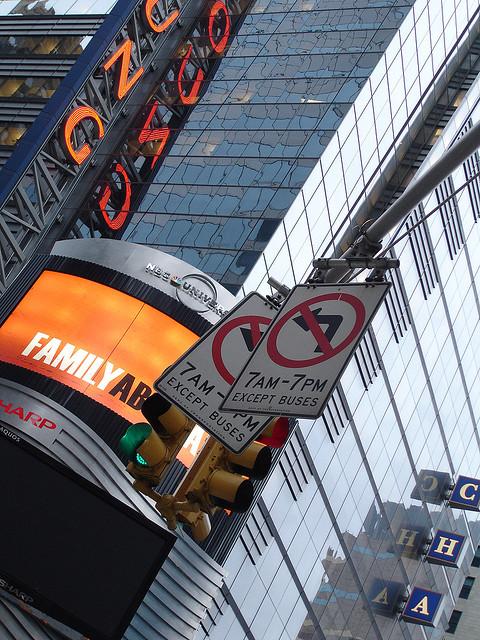When is it legal to make a left turn?
Give a very brief answer. 7am-7pm. How many traffic lights are here?
Short answer required. 2. What does the orange sign say?
Short answer required. Family ab. 